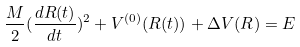Convert formula to latex. <formula><loc_0><loc_0><loc_500><loc_500>\frac { M } { 2 } ( \frac { d R ( t ) } { d t } ) ^ { 2 } + V ^ { ( 0 ) } ( R ( t ) ) + \Delta V ( R ) = E</formula> 